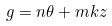<formula> <loc_0><loc_0><loc_500><loc_500>g = n \theta + m k z</formula> 